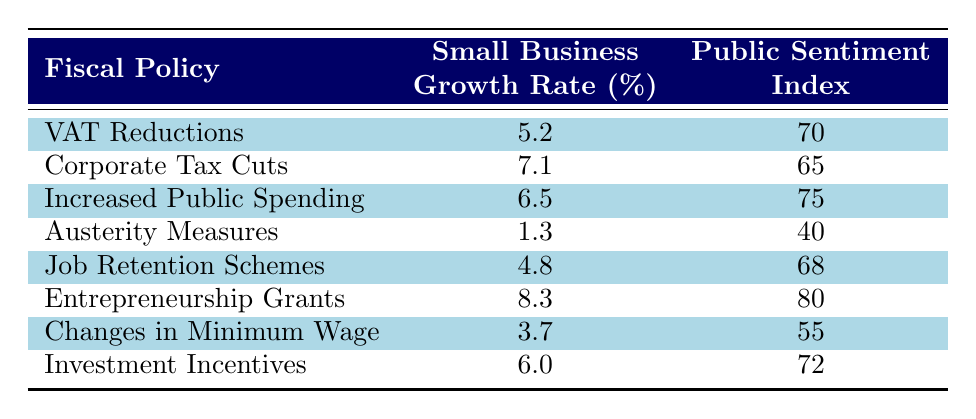What is the small business growth rate for Entrepreneurship Grants? According to the table, the small business growth rate associated with Entrepreneurship Grants is directly listed as 8.3%.
Answer: 8.3% Which fiscal policy has the lowest public sentiment index? The lowest public sentiment index in the table is associated with Austerity Measures, where the index is 40.
Answer: Austerity Measures What is the difference in small business growth rates between Job Retention Schemes and Changes in Minimum Wage? Looking at the growth rates, Job Retention Schemes have a rate of 4.8% while Changes in Minimum Wage have a rate of 3.7%. The difference is 4.8 - 3.7 = 1.1%.
Answer: 1.1% Does increased public spending contribute to a higher public sentiment index compared to corporate tax cuts? The public sentiment index for Increased Public Spending is 75, while for Corporate Tax Cuts, it is 65. Since 75 is greater than 65, increased public spending does indeed contribute to a higher sentiment index.
Answer: Yes What is the average growth rate of small businesses under fiscal policies that have a public sentiment index of 70 or higher? The relevant fiscal policies with a public sentiment index of 70 or higher are VAT Reductions (5.2%), Increased Public Spending (6.5%), Entrepreneurship Grants (8.3%), and Investment Incentives (6.0%). Adding these values gives 5.2 + 6.5 + 8.3 + 6.0 = 26.0, and dividing by 4 gives an average growth rate of 26.0/4 = 6.5%.
Answer: 6.5% Which fiscal policy shows a combination of low small business growth and low public sentiment? The fiscal policy that shows both low small business growth and low public sentiment is Austerity Measures, with a growth rate of 1.3% and a sentiment index of 40.
Answer: Austerity Measures 